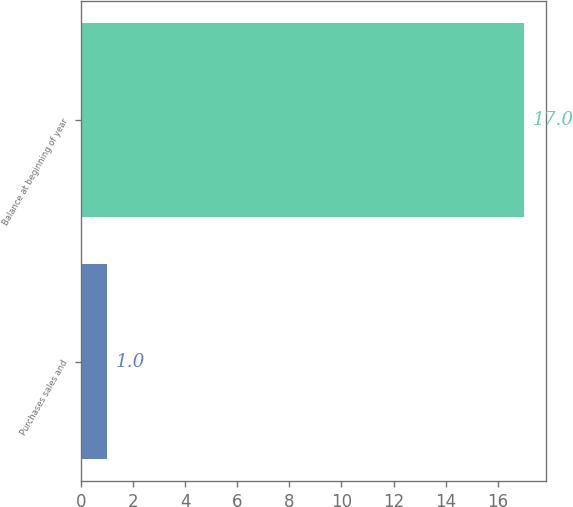<chart> <loc_0><loc_0><loc_500><loc_500><bar_chart><fcel>Purchases sales and<fcel>Balance at beginning of year<nl><fcel>1<fcel>17<nl></chart> 